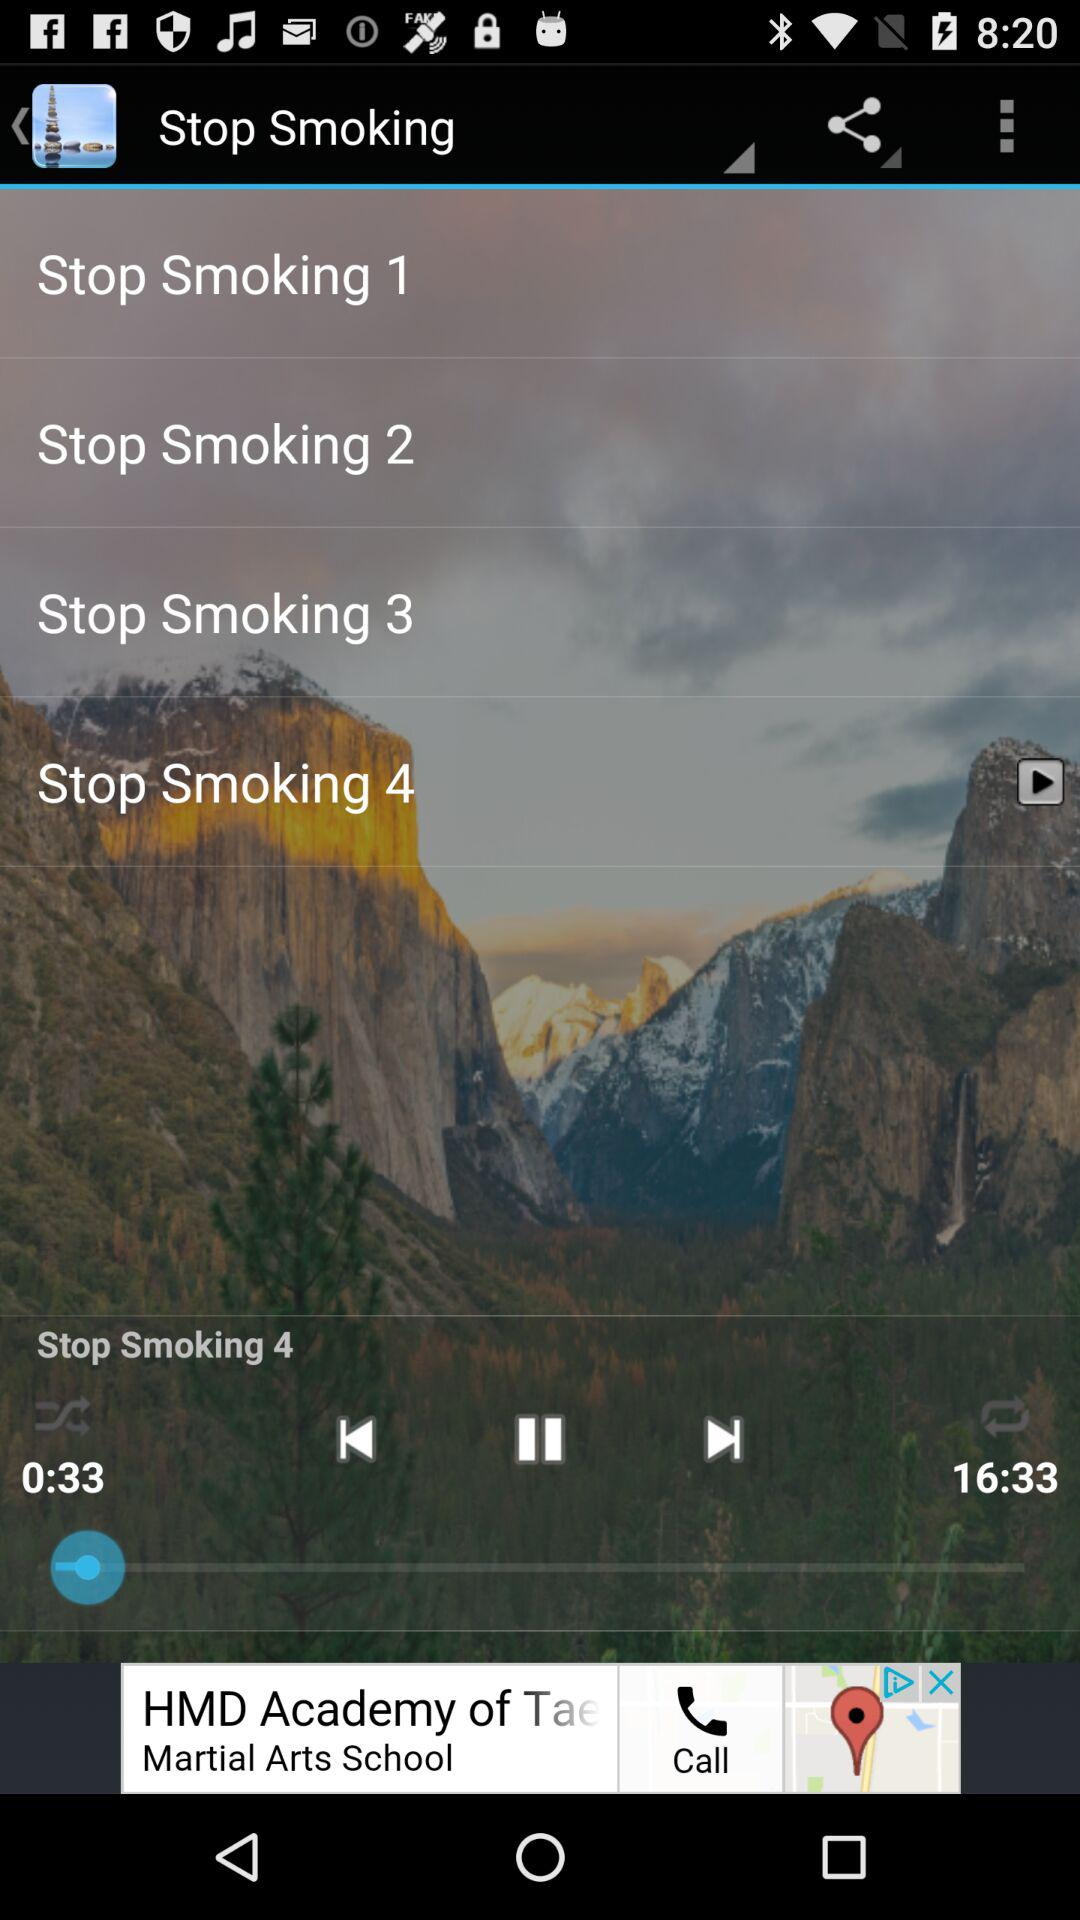Which track is playing? The track "Stop Smoking 4" is playing. 